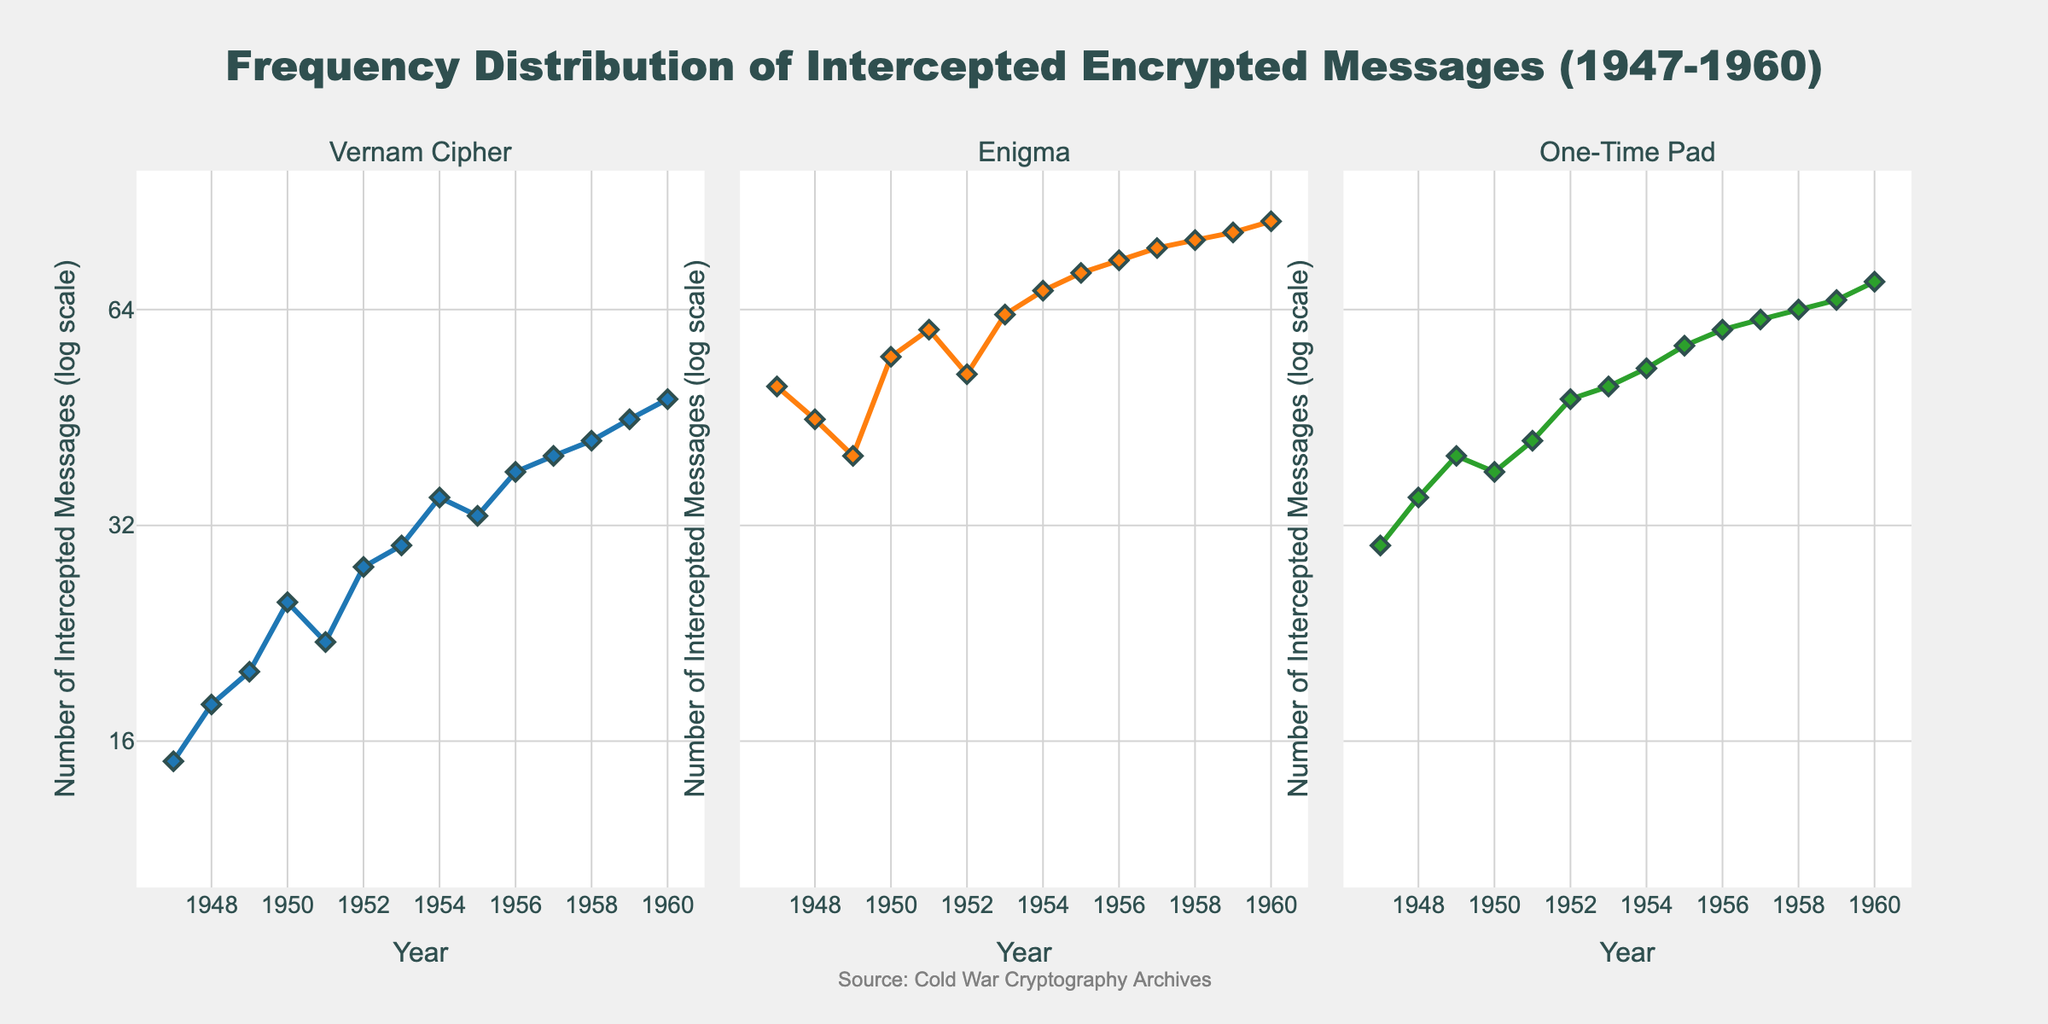what's the title of the plot? The title can be seen at the top of the figure. It reads "Frequency Distribution of Intercepted Encrypted Messages (1947-1960)".
Answer: Frequency Distribution of Intercepted Encrypted Messages (1947-1960) what is the log scale range for the y-axis? The y-axis is presented in a logarithmic scale, with the range indicating intercepted messages from 10 to 100.
Answer: 10 to 100 how many encryption types are displayed in the subplots? Examining the titles of the subplots and the legend shows three types of encryption: Vernam Cipher, Enigma, and One-Time Pad.
Answer: 3 which year had the highest number of intercepted Enigma messages? By observing the Enigma subplot, the year 1960 had the highest point on the curve, corresponding to 85 intercepted messages.
Answer: 1960 what is the overall trend in the number of intercepted messages from 1947 to 1960 for the Vernam Cipher? The Vernam Cipher shows an upward trend, starting from a lower left position and moving progressively higher to the right, indicating an increase in intercepted messages over the years.
Answer: Increasing how does the trend of intercepted messages for the One-Time Pad from 1947 to 1953 compare to the trend from 1954 to 1960? The One-Time Pad shows a slower increase in intercepted messages from 1947 to 1953 and a faster rise from 1954 to 1960, with more rapid growth in the latter period.
Answer: Slower increase initially, faster increase later in which subplot do you notice the steepest rise in intercepted messages over the years? The Enigma subplot exhibits the steepest rise in intercepted messages over the years, with a steeper slope compared to the Vernam Cipher and One-Time Pad.
Answer: Enigma if you average the intercepted messages for all years for the Vernam Cipher, what would be the approximate value? Sum the Vernam Cipher values (15 + 18 + 20 + 25 + 22 + 28 + 30 + 35 + 33 + 38 + 40 + 42 + 45 + 48) which gives 439, then divide by the number of years (14) to get approximately 31.36.
Answer: 31.36 is the number of intercepted One-Time Pad messages in 1954 greater than the number for the same encryption type in 1953? By comparing the data points for the One-Time Pad on the log scale, the number in 1954 (53) is indeed greater than in 1953 (50).
Answer: Yes 